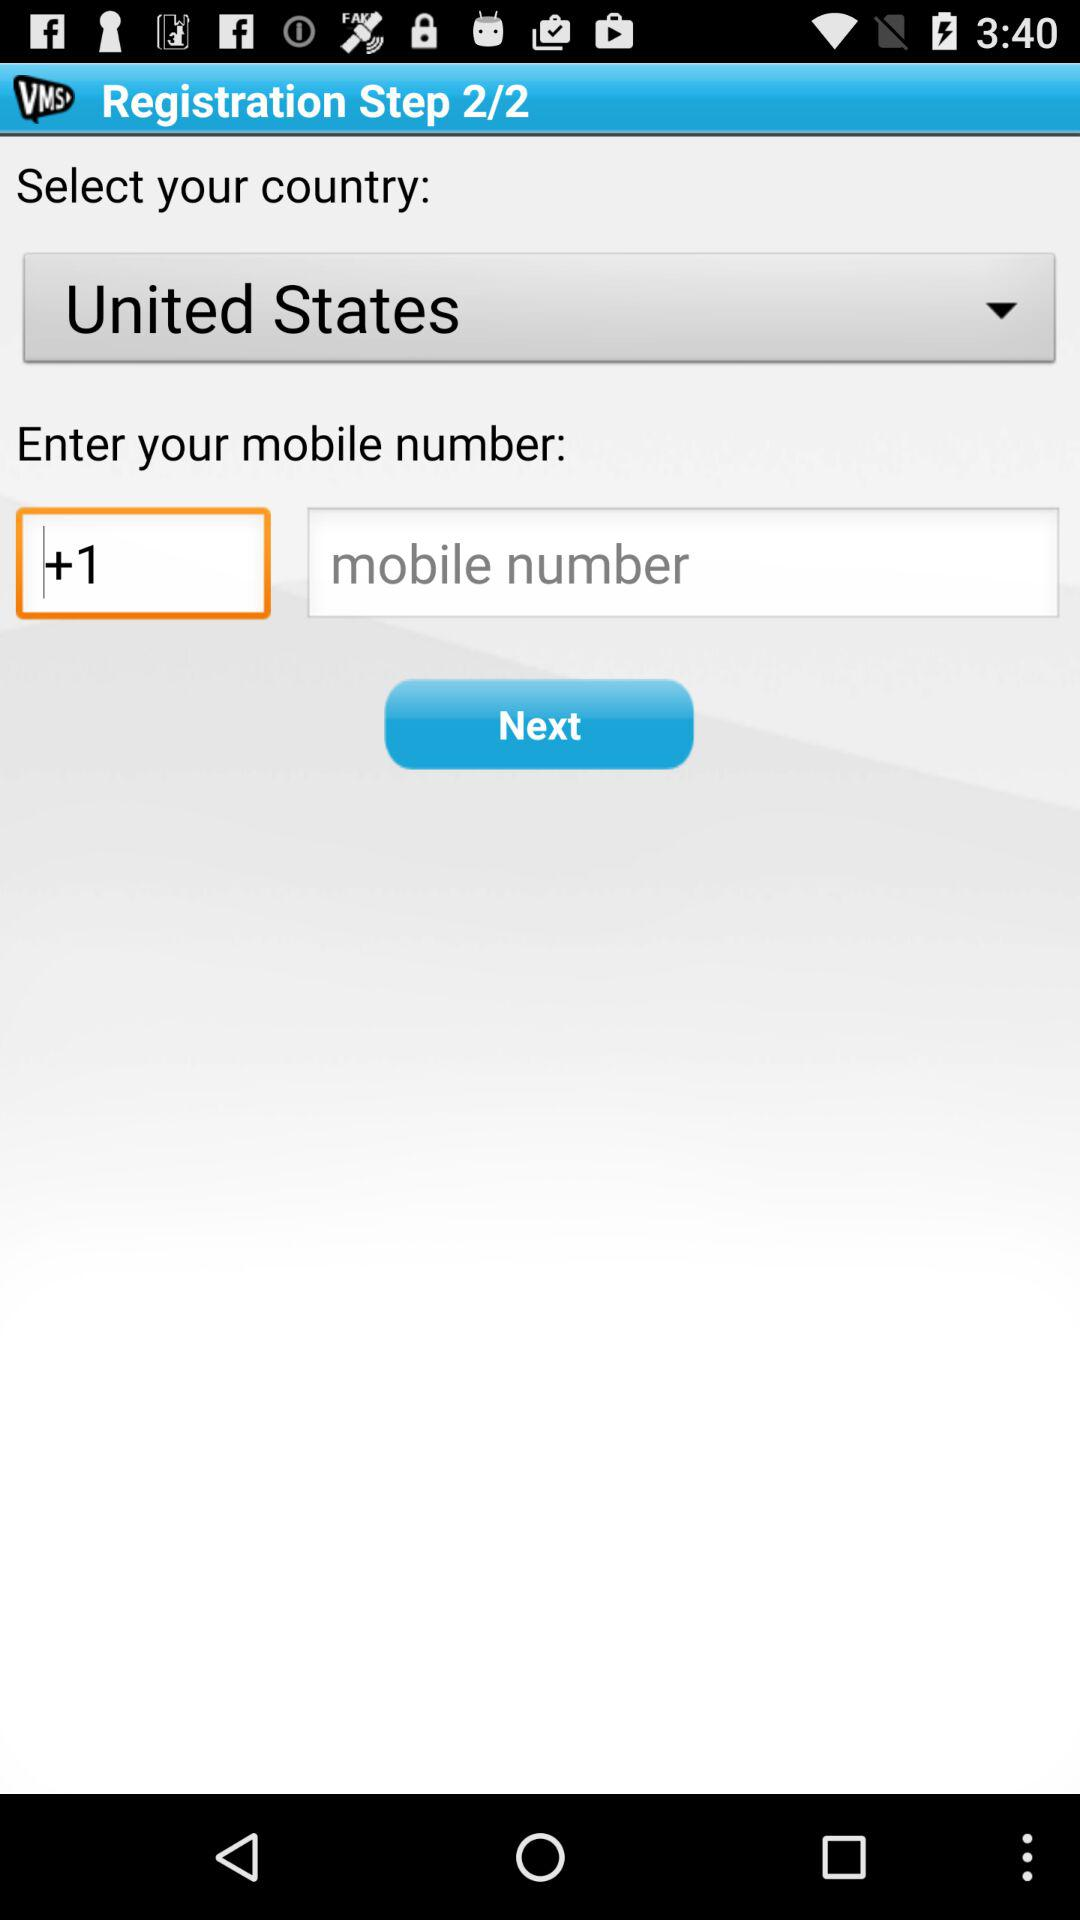At which step are we? You are at step 2. 